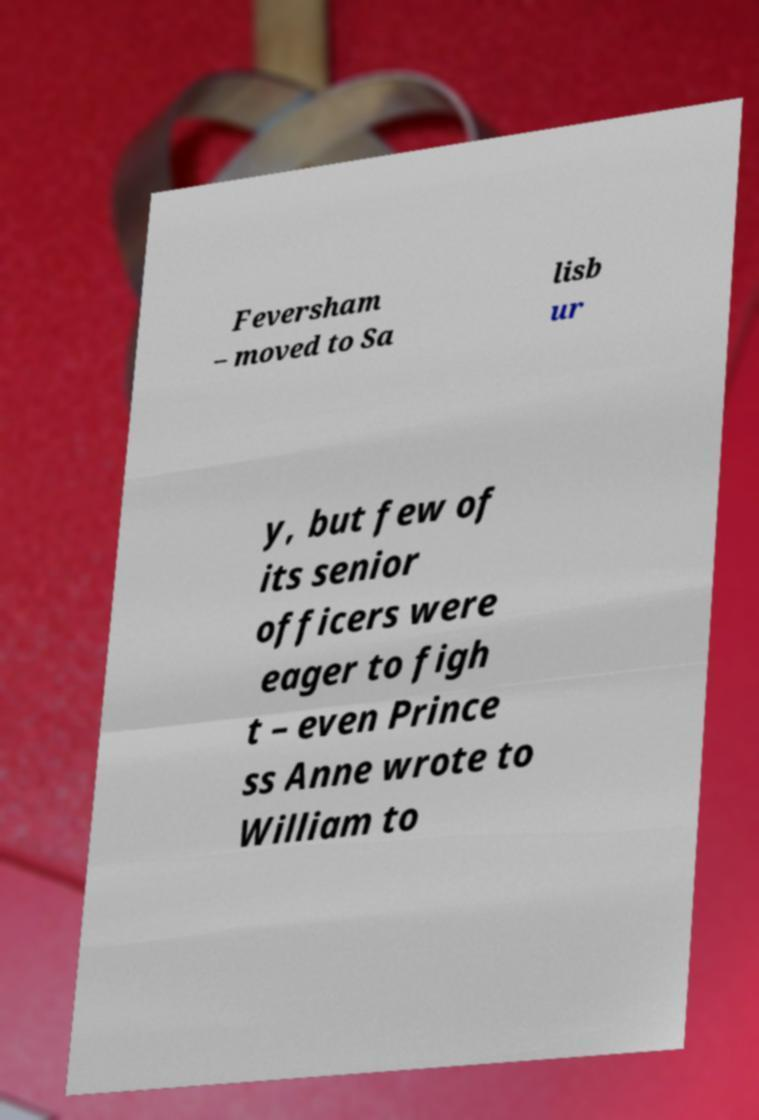I need the written content from this picture converted into text. Can you do that? Feversham – moved to Sa lisb ur y, but few of its senior officers were eager to figh t – even Prince ss Anne wrote to William to 